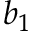<formula> <loc_0><loc_0><loc_500><loc_500>b _ { 1 }</formula> 